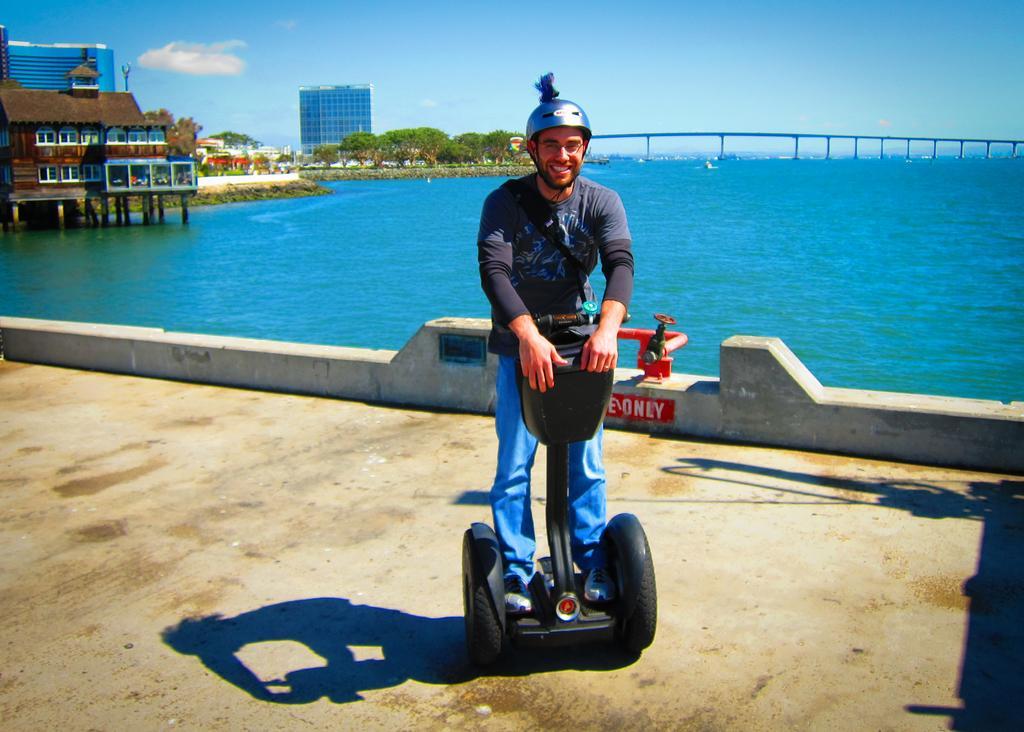Can you describe this image briefly? In the picture we can see a path on it we can see a man with two wheels vehicle holding it and he is with helmet and smiling and behind him we can see a wall and behind it we can see water which is blue in color and beside it we can see some houses with glass windows to it and beside it we can see some trees and building with glasses and beside it we can see a bridge on the water and behind it we can see sky with clouds. 